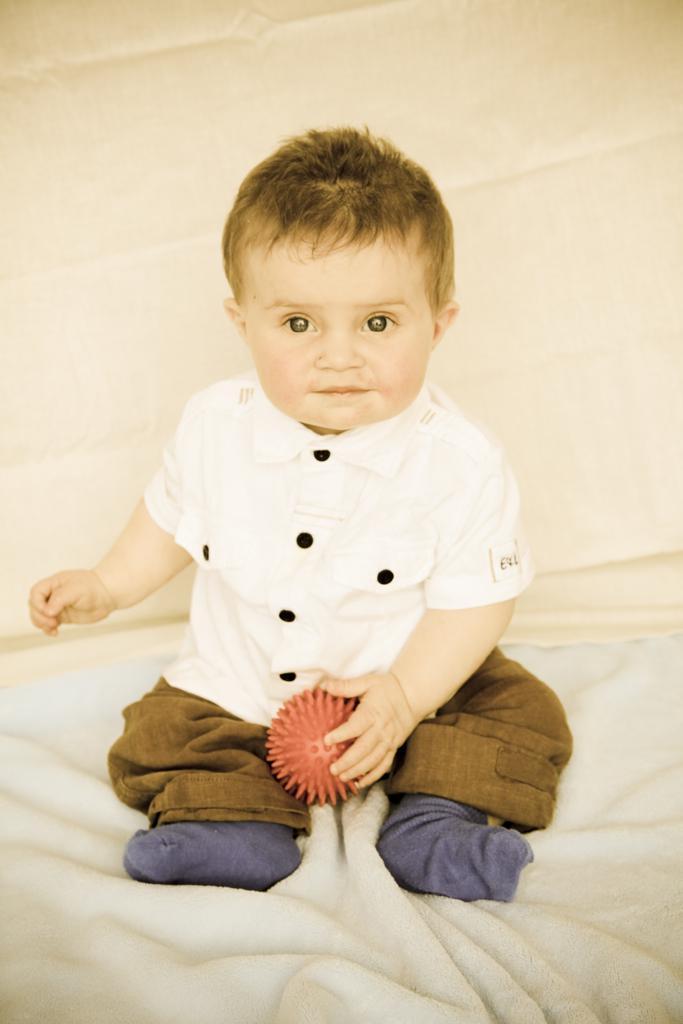Please provide a concise description of this image. In this picture we can see a boy is in the white shirt. He is holding an object and sitting on a cloth. Behind the boy, it looks like a wall. 